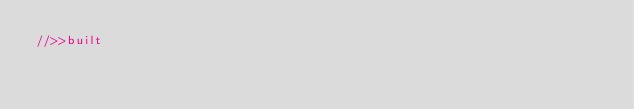<code> <loc_0><loc_0><loc_500><loc_500><_JavaScript_>//>>built</code> 